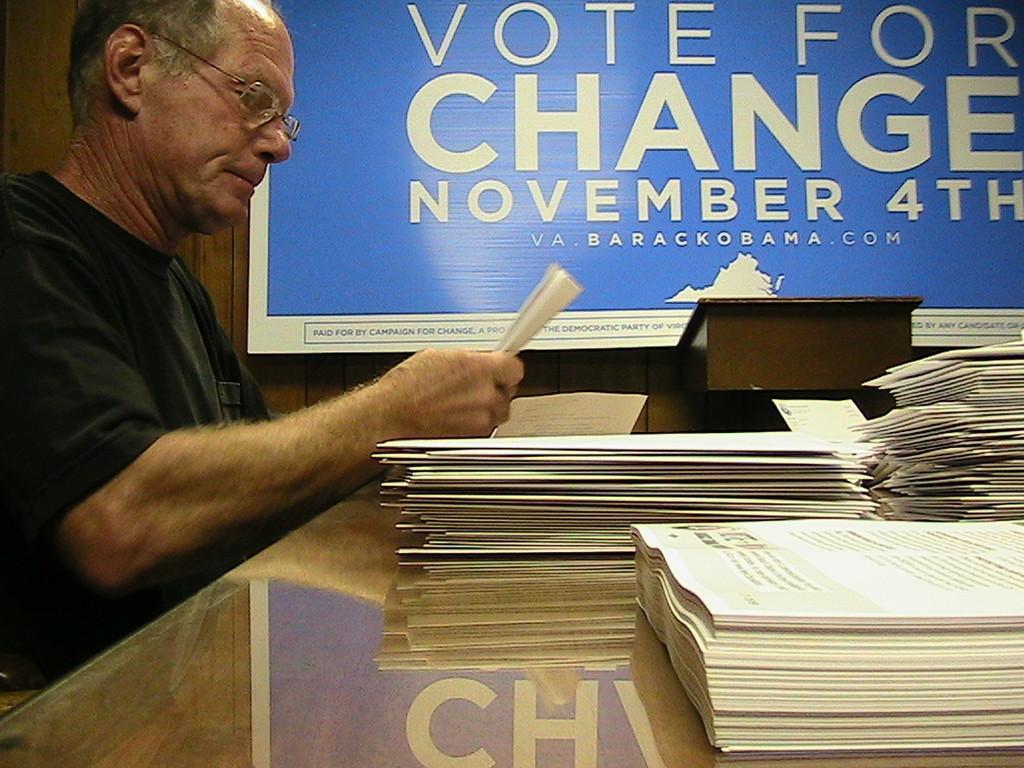How would you summarize this image in a sentence or two? On the left side of the image a man is sitting and holding a booklet. In the center of the image we can see a table. On the table booklets are present. At the top of the image a board is there. At the top left corner a wall is present. 